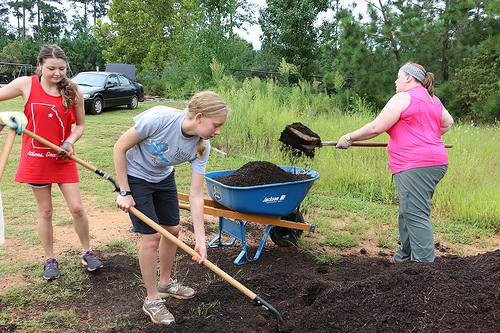<image>
Can you confirm if the black dirt is on the light dirt? Yes. Looking at the image, I can see the black dirt is positioned on top of the light dirt, with the light dirt providing support. 